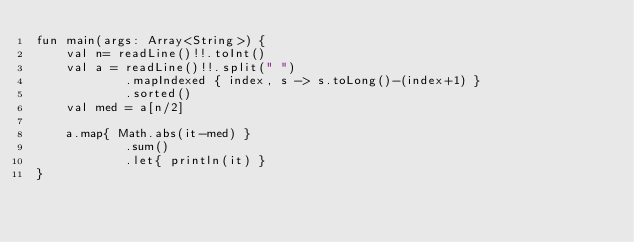<code> <loc_0><loc_0><loc_500><loc_500><_Kotlin_>fun main(args: Array<String>) {
    val n= readLine()!!.toInt()
    val a = readLine()!!.split(" ")
            .mapIndexed { index, s -> s.toLong()-(index+1) }
            .sorted()
    val med = a[n/2]

    a.map{ Math.abs(it-med) }
            .sum()
            .let{ println(it) }
}</code> 